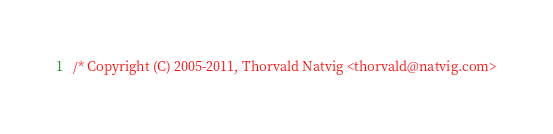<code> <loc_0><loc_0><loc_500><loc_500><_ObjectiveC_>/* Copyright (C) 2005-2011, Thorvald Natvig <thorvald@natvig.com></code> 